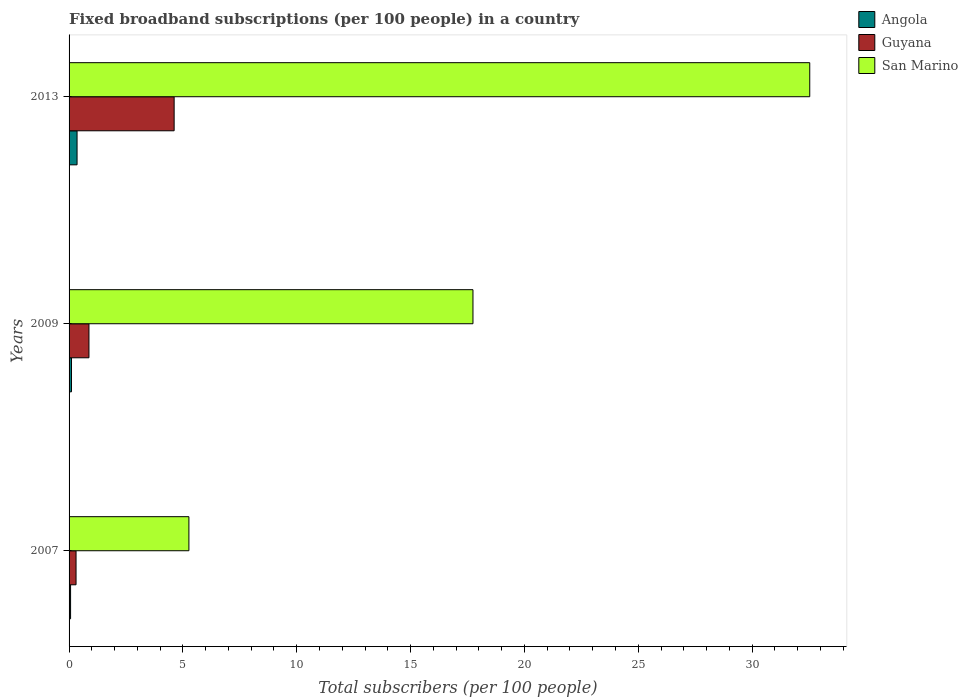Are the number of bars per tick equal to the number of legend labels?
Provide a succinct answer. Yes. Are the number of bars on each tick of the Y-axis equal?
Offer a terse response. Yes. How many bars are there on the 1st tick from the top?
Give a very brief answer. 3. How many bars are there on the 2nd tick from the bottom?
Make the answer very short. 3. What is the label of the 1st group of bars from the top?
Your response must be concise. 2013. What is the number of broadband subscriptions in Angola in 2013?
Your answer should be compact. 0.35. Across all years, what is the maximum number of broadband subscriptions in San Marino?
Give a very brief answer. 32.53. Across all years, what is the minimum number of broadband subscriptions in Angola?
Ensure brevity in your answer.  0.07. What is the total number of broadband subscriptions in Guyana in the graph?
Ensure brevity in your answer.  5.79. What is the difference between the number of broadband subscriptions in Guyana in 2009 and that in 2013?
Your response must be concise. -3.74. What is the difference between the number of broadband subscriptions in Guyana in 2009 and the number of broadband subscriptions in San Marino in 2013?
Offer a very short reply. -31.66. What is the average number of broadband subscriptions in San Marino per year?
Provide a succinct answer. 18.51. In the year 2009, what is the difference between the number of broadband subscriptions in Guyana and number of broadband subscriptions in Angola?
Your answer should be compact. 0.77. In how many years, is the number of broadband subscriptions in San Marino greater than 26 ?
Make the answer very short. 1. What is the ratio of the number of broadband subscriptions in Angola in 2009 to that in 2013?
Your answer should be compact. 0.3. What is the difference between the highest and the second highest number of broadband subscriptions in Angola?
Your response must be concise. 0.25. What is the difference between the highest and the lowest number of broadband subscriptions in Guyana?
Offer a terse response. 4.31. In how many years, is the number of broadband subscriptions in San Marino greater than the average number of broadband subscriptions in San Marino taken over all years?
Your answer should be compact. 1. Is the sum of the number of broadband subscriptions in Guyana in 2007 and 2009 greater than the maximum number of broadband subscriptions in Angola across all years?
Provide a short and direct response. Yes. What does the 3rd bar from the top in 2007 represents?
Keep it short and to the point. Angola. What does the 3rd bar from the bottom in 2009 represents?
Your response must be concise. San Marino. Is it the case that in every year, the sum of the number of broadband subscriptions in Angola and number of broadband subscriptions in San Marino is greater than the number of broadband subscriptions in Guyana?
Your response must be concise. Yes. How many bars are there?
Provide a short and direct response. 9. How many years are there in the graph?
Your answer should be very brief. 3. What is the difference between two consecutive major ticks on the X-axis?
Ensure brevity in your answer.  5. Are the values on the major ticks of X-axis written in scientific E-notation?
Your answer should be very brief. No. Does the graph contain any zero values?
Keep it short and to the point. No. Where does the legend appear in the graph?
Offer a terse response. Top right. How are the legend labels stacked?
Keep it short and to the point. Vertical. What is the title of the graph?
Make the answer very short. Fixed broadband subscriptions (per 100 people) in a country. Does "Spain" appear as one of the legend labels in the graph?
Ensure brevity in your answer.  No. What is the label or title of the X-axis?
Keep it short and to the point. Total subscribers (per 100 people). What is the Total subscribers (per 100 people) in Angola in 2007?
Give a very brief answer. 0.07. What is the Total subscribers (per 100 people) of Guyana in 2007?
Your answer should be compact. 0.31. What is the Total subscribers (per 100 people) in San Marino in 2007?
Give a very brief answer. 5.26. What is the Total subscribers (per 100 people) in Angola in 2009?
Your response must be concise. 0.11. What is the Total subscribers (per 100 people) in Guyana in 2009?
Provide a succinct answer. 0.87. What is the Total subscribers (per 100 people) of San Marino in 2009?
Your answer should be compact. 17.74. What is the Total subscribers (per 100 people) of Angola in 2013?
Keep it short and to the point. 0.35. What is the Total subscribers (per 100 people) in Guyana in 2013?
Offer a very short reply. 4.61. What is the Total subscribers (per 100 people) of San Marino in 2013?
Your response must be concise. 32.53. Across all years, what is the maximum Total subscribers (per 100 people) in Angola?
Keep it short and to the point. 0.35. Across all years, what is the maximum Total subscribers (per 100 people) in Guyana?
Your answer should be very brief. 4.61. Across all years, what is the maximum Total subscribers (per 100 people) of San Marino?
Your answer should be very brief. 32.53. Across all years, what is the minimum Total subscribers (per 100 people) in Angola?
Provide a succinct answer. 0.07. Across all years, what is the minimum Total subscribers (per 100 people) in Guyana?
Offer a very short reply. 0.31. Across all years, what is the minimum Total subscribers (per 100 people) in San Marino?
Your answer should be compact. 5.26. What is the total Total subscribers (per 100 people) of Angola in the graph?
Ensure brevity in your answer.  0.52. What is the total Total subscribers (per 100 people) in Guyana in the graph?
Ensure brevity in your answer.  5.79. What is the total Total subscribers (per 100 people) of San Marino in the graph?
Offer a very short reply. 55.54. What is the difference between the Total subscribers (per 100 people) in Angola in 2007 and that in 2009?
Make the answer very short. -0.04. What is the difference between the Total subscribers (per 100 people) in Guyana in 2007 and that in 2009?
Provide a succinct answer. -0.57. What is the difference between the Total subscribers (per 100 people) in San Marino in 2007 and that in 2009?
Make the answer very short. -12.48. What is the difference between the Total subscribers (per 100 people) in Angola in 2007 and that in 2013?
Your answer should be very brief. -0.28. What is the difference between the Total subscribers (per 100 people) of Guyana in 2007 and that in 2013?
Offer a very short reply. -4.31. What is the difference between the Total subscribers (per 100 people) of San Marino in 2007 and that in 2013?
Make the answer very short. -27.27. What is the difference between the Total subscribers (per 100 people) in Angola in 2009 and that in 2013?
Your response must be concise. -0.25. What is the difference between the Total subscribers (per 100 people) in Guyana in 2009 and that in 2013?
Your answer should be compact. -3.74. What is the difference between the Total subscribers (per 100 people) of San Marino in 2009 and that in 2013?
Offer a terse response. -14.79. What is the difference between the Total subscribers (per 100 people) of Angola in 2007 and the Total subscribers (per 100 people) of Guyana in 2009?
Your answer should be compact. -0.81. What is the difference between the Total subscribers (per 100 people) in Angola in 2007 and the Total subscribers (per 100 people) in San Marino in 2009?
Make the answer very short. -17.67. What is the difference between the Total subscribers (per 100 people) of Guyana in 2007 and the Total subscribers (per 100 people) of San Marino in 2009?
Give a very brief answer. -17.43. What is the difference between the Total subscribers (per 100 people) of Angola in 2007 and the Total subscribers (per 100 people) of Guyana in 2013?
Offer a terse response. -4.55. What is the difference between the Total subscribers (per 100 people) of Angola in 2007 and the Total subscribers (per 100 people) of San Marino in 2013?
Offer a terse response. -32.47. What is the difference between the Total subscribers (per 100 people) in Guyana in 2007 and the Total subscribers (per 100 people) in San Marino in 2013?
Offer a very short reply. -32.23. What is the difference between the Total subscribers (per 100 people) in Angola in 2009 and the Total subscribers (per 100 people) in Guyana in 2013?
Offer a very short reply. -4.51. What is the difference between the Total subscribers (per 100 people) of Angola in 2009 and the Total subscribers (per 100 people) of San Marino in 2013?
Offer a very short reply. -32.43. What is the difference between the Total subscribers (per 100 people) in Guyana in 2009 and the Total subscribers (per 100 people) in San Marino in 2013?
Your response must be concise. -31.66. What is the average Total subscribers (per 100 people) in Angola per year?
Provide a short and direct response. 0.17. What is the average Total subscribers (per 100 people) in Guyana per year?
Offer a very short reply. 1.93. What is the average Total subscribers (per 100 people) of San Marino per year?
Give a very brief answer. 18.51. In the year 2007, what is the difference between the Total subscribers (per 100 people) of Angola and Total subscribers (per 100 people) of Guyana?
Your response must be concise. -0.24. In the year 2007, what is the difference between the Total subscribers (per 100 people) of Angola and Total subscribers (per 100 people) of San Marino?
Provide a short and direct response. -5.2. In the year 2007, what is the difference between the Total subscribers (per 100 people) in Guyana and Total subscribers (per 100 people) in San Marino?
Your answer should be compact. -4.96. In the year 2009, what is the difference between the Total subscribers (per 100 people) of Angola and Total subscribers (per 100 people) of Guyana?
Offer a very short reply. -0.77. In the year 2009, what is the difference between the Total subscribers (per 100 people) in Angola and Total subscribers (per 100 people) in San Marino?
Your answer should be compact. -17.63. In the year 2009, what is the difference between the Total subscribers (per 100 people) in Guyana and Total subscribers (per 100 people) in San Marino?
Keep it short and to the point. -16.87. In the year 2013, what is the difference between the Total subscribers (per 100 people) in Angola and Total subscribers (per 100 people) in Guyana?
Make the answer very short. -4.26. In the year 2013, what is the difference between the Total subscribers (per 100 people) in Angola and Total subscribers (per 100 people) in San Marino?
Give a very brief answer. -32.18. In the year 2013, what is the difference between the Total subscribers (per 100 people) of Guyana and Total subscribers (per 100 people) of San Marino?
Your answer should be compact. -27.92. What is the ratio of the Total subscribers (per 100 people) in Angola in 2007 to that in 2009?
Give a very brief answer. 0.63. What is the ratio of the Total subscribers (per 100 people) of Guyana in 2007 to that in 2009?
Keep it short and to the point. 0.35. What is the ratio of the Total subscribers (per 100 people) in San Marino in 2007 to that in 2009?
Provide a short and direct response. 0.3. What is the ratio of the Total subscribers (per 100 people) in Angola in 2007 to that in 2013?
Provide a succinct answer. 0.19. What is the ratio of the Total subscribers (per 100 people) of Guyana in 2007 to that in 2013?
Provide a succinct answer. 0.07. What is the ratio of the Total subscribers (per 100 people) of San Marino in 2007 to that in 2013?
Provide a short and direct response. 0.16. What is the ratio of the Total subscribers (per 100 people) in Angola in 2009 to that in 2013?
Give a very brief answer. 0.3. What is the ratio of the Total subscribers (per 100 people) in Guyana in 2009 to that in 2013?
Ensure brevity in your answer.  0.19. What is the ratio of the Total subscribers (per 100 people) of San Marino in 2009 to that in 2013?
Give a very brief answer. 0.55. What is the difference between the highest and the second highest Total subscribers (per 100 people) of Angola?
Offer a very short reply. 0.25. What is the difference between the highest and the second highest Total subscribers (per 100 people) of Guyana?
Provide a succinct answer. 3.74. What is the difference between the highest and the second highest Total subscribers (per 100 people) in San Marino?
Provide a succinct answer. 14.79. What is the difference between the highest and the lowest Total subscribers (per 100 people) of Angola?
Your answer should be compact. 0.28. What is the difference between the highest and the lowest Total subscribers (per 100 people) of Guyana?
Offer a very short reply. 4.31. What is the difference between the highest and the lowest Total subscribers (per 100 people) in San Marino?
Provide a short and direct response. 27.27. 